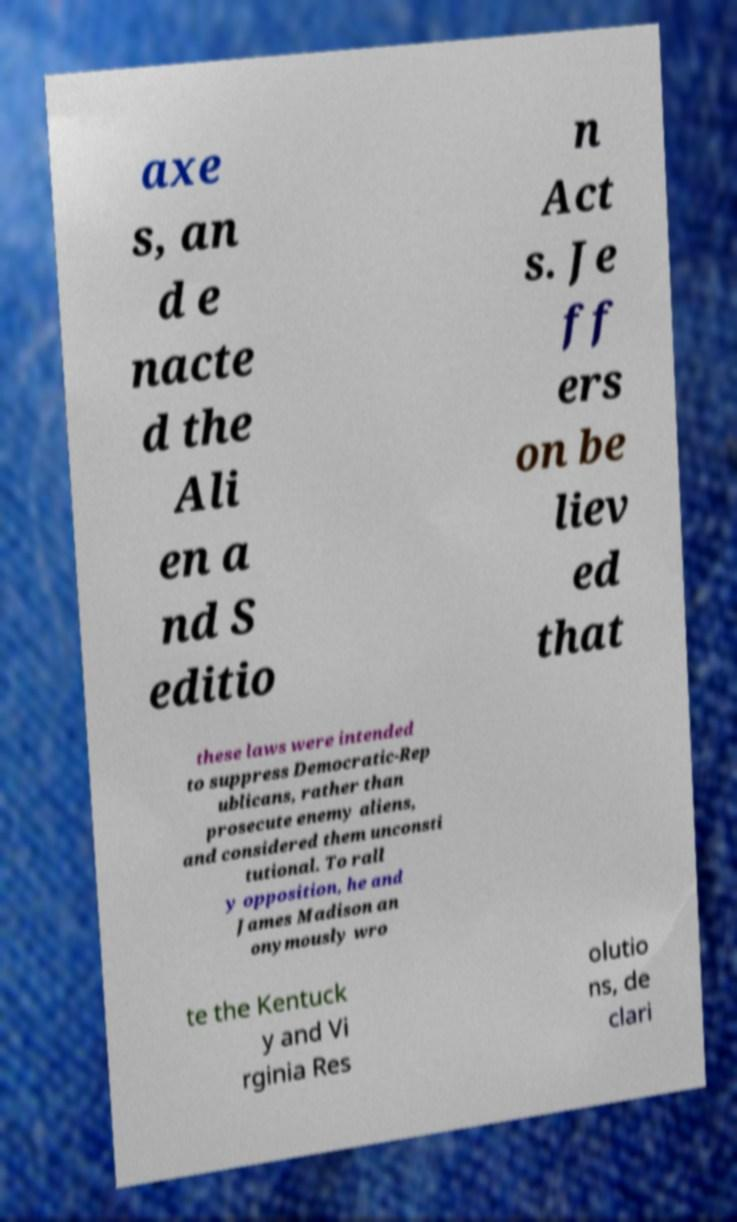Can you read and provide the text displayed in the image?This photo seems to have some interesting text. Can you extract and type it out for me? axe s, an d e nacte d the Ali en a nd S editio n Act s. Je ff ers on be liev ed that these laws were intended to suppress Democratic-Rep ublicans, rather than prosecute enemy aliens, and considered them unconsti tutional. To rall y opposition, he and James Madison an onymously wro te the Kentuck y and Vi rginia Res olutio ns, de clari 